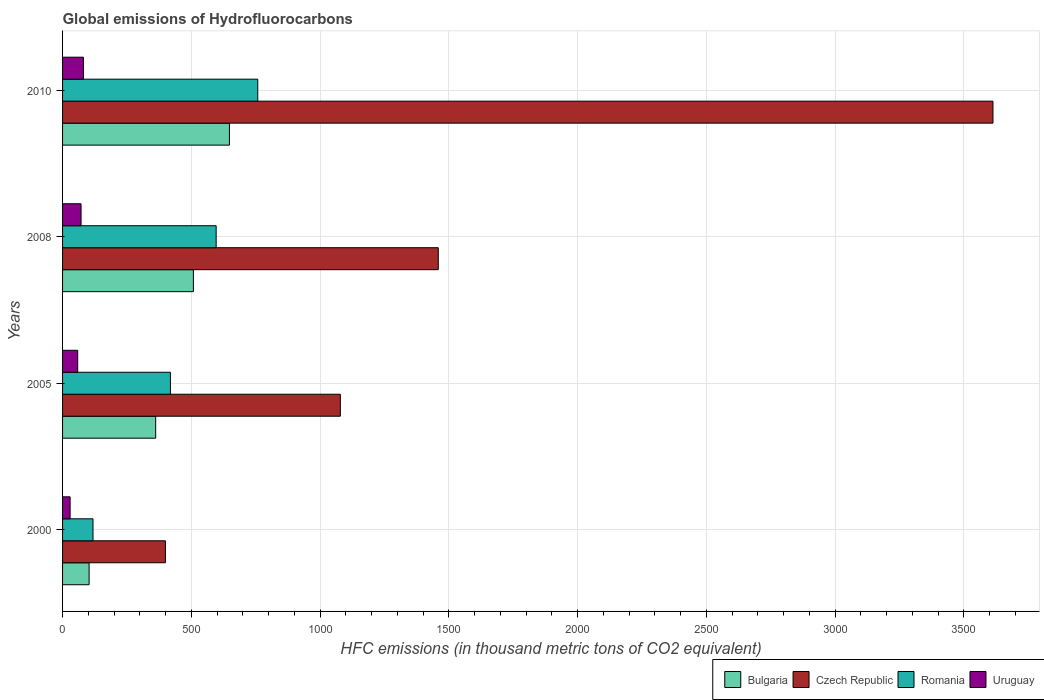How many groups of bars are there?
Make the answer very short. 4. How many bars are there on the 4th tick from the bottom?
Provide a succinct answer. 4. What is the label of the 2nd group of bars from the top?
Your response must be concise. 2008. What is the global emissions of Hydrofluorocarbons in Bulgaria in 2008?
Provide a succinct answer. 508. Across all years, what is the maximum global emissions of Hydrofluorocarbons in Bulgaria?
Give a very brief answer. 648. Across all years, what is the minimum global emissions of Hydrofluorocarbons in Romania?
Offer a terse response. 118.2. In which year was the global emissions of Hydrofluorocarbons in Bulgaria maximum?
Offer a terse response. 2010. What is the total global emissions of Hydrofluorocarbons in Czech Republic in the graph?
Offer a very short reply. 6550.2. What is the difference between the global emissions of Hydrofluorocarbons in Czech Republic in 2000 and that in 2005?
Make the answer very short. -679.2. What is the difference between the global emissions of Hydrofluorocarbons in Bulgaria in 2000 and the global emissions of Hydrofluorocarbons in Uruguay in 2008?
Offer a very short reply. 31.3. What is the average global emissions of Hydrofluorocarbons in Bulgaria per year?
Keep it short and to the point. 405.18. In the year 2008, what is the difference between the global emissions of Hydrofluorocarbons in Romania and global emissions of Hydrofluorocarbons in Bulgaria?
Offer a terse response. 88.4. In how many years, is the global emissions of Hydrofluorocarbons in Czech Republic greater than 400 thousand metric tons?
Provide a succinct answer. 3. What is the ratio of the global emissions of Hydrofluorocarbons in Uruguay in 2000 to that in 2008?
Provide a short and direct response. 0.41. Is the global emissions of Hydrofluorocarbons in Uruguay in 2000 less than that in 2005?
Make the answer very short. Yes. Is the difference between the global emissions of Hydrofluorocarbons in Romania in 2000 and 2005 greater than the difference between the global emissions of Hydrofluorocarbons in Bulgaria in 2000 and 2005?
Make the answer very short. No. What is the difference between the highest and the second highest global emissions of Hydrofluorocarbons in Romania?
Ensure brevity in your answer.  161.6. What is the difference between the highest and the lowest global emissions of Hydrofluorocarbons in Bulgaria?
Provide a short and direct response. 544.9. Is it the case that in every year, the sum of the global emissions of Hydrofluorocarbons in Romania and global emissions of Hydrofluorocarbons in Czech Republic is greater than the sum of global emissions of Hydrofluorocarbons in Uruguay and global emissions of Hydrofluorocarbons in Bulgaria?
Provide a short and direct response. Yes. What does the 1st bar from the top in 2008 represents?
Provide a short and direct response. Uruguay. What does the 3rd bar from the bottom in 2010 represents?
Your answer should be very brief. Romania. Is it the case that in every year, the sum of the global emissions of Hydrofluorocarbons in Uruguay and global emissions of Hydrofluorocarbons in Czech Republic is greater than the global emissions of Hydrofluorocarbons in Romania?
Your answer should be very brief. Yes. How many bars are there?
Provide a short and direct response. 16. Does the graph contain any zero values?
Your response must be concise. No. Does the graph contain grids?
Your response must be concise. Yes. Where does the legend appear in the graph?
Your answer should be compact. Bottom right. What is the title of the graph?
Your answer should be very brief. Global emissions of Hydrofluorocarbons. What is the label or title of the X-axis?
Offer a very short reply. HFC emissions (in thousand metric tons of CO2 equivalent). What is the label or title of the Y-axis?
Your answer should be compact. Years. What is the HFC emissions (in thousand metric tons of CO2 equivalent) of Bulgaria in 2000?
Provide a short and direct response. 103.1. What is the HFC emissions (in thousand metric tons of CO2 equivalent) in Czech Republic in 2000?
Your answer should be very brief. 399.5. What is the HFC emissions (in thousand metric tons of CO2 equivalent) in Romania in 2000?
Provide a short and direct response. 118.2. What is the HFC emissions (in thousand metric tons of CO2 equivalent) of Uruguay in 2000?
Offer a very short reply. 29.3. What is the HFC emissions (in thousand metric tons of CO2 equivalent) in Bulgaria in 2005?
Your response must be concise. 361.6. What is the HFC emissions (in thousand metric tons of CO2 equivalent) in Czech Republic in 2005?
Give a very brief answer. 1078.7. What is the HFC emissions (in thousand metric tons of CO2 equivalent) of Romania in 2005?
Offer a very short reply. 418.8. What is the HFC emissions (in thousand metric tons of CO2 equivalent) in Uruguay in 2005?
Your answer should be very brief. 58.7. What is the HFC emissions (in thousand metric tons of CO2 equivalent) in Bulgaria in 2008?
Provide a succinct answer. 508. What is the HFC emissions (in thousand metric tons of CO2 equivalent) of Czech Republic in 2008?
Keep it short and to the point. 1459. What is the HFC emissions (in thousand metric tons of CO2 equivalent) of Romania in 2008?
Provide a succinct answer. 596.4. What is the HFC emissions (in thousand metric tons of CO2 equivalent) of Uruguay in 2008?
Ensure brevity in your answer.  71.8. What is the HFC emissions (in thousand metric tons of CO2 equivalent) in Bulgaria in 2010?
Your answer should be compact. 648. What is the HFC emissions (in thousand metric tons of CO2 equivalent) in Czech Republic in 2010?
Your answer should be very brief. 3613. What is the HFC emissions (in thousand metric tons of CO2 equivalent) of Romania in 2010?
Your response must be concise. 758. What is the HFC emissions (in thousand metric tons of CO2 equivalent) of Uruguay in 2010?
Your answer should be very brief. 81. Across all years, what is the maximum HFC emissions (in thousand metric tons of CO2 equivalent) of Bulgaria?
Keep it short and to the point. 648. Across all years, what is the maximum HFC emissions (in thousand metric tons of CO2 equivalent) in Czech Republic?
Your answer should be very brief. 3613. Across all years, what is the maximum HFC emissions (in thousand metric tons of CO2 equivalent) of Romania?
Provide a short and direct response. 758. Across all years, what is the minimum HFC emissions (in thousand metric tons of CO2 equivalent) in Bulgaria?
Your answer should be very brief. 103.1. Across all years, what is the minimum HFC emissions (in thousand metric tons of CO2 equivalent) of Czech Republic?
Offer a terse response. 399.5. Across all years, what is the minimum HFC emissions (in thousand metric tons of CO2 equivalent) in Romania?
Give a very brief answer. 118.2. Across all years, what is the minimum HFC emissions (in thousand metric tons of CO2 equivalent) in Uruguay?
Ensure brevity in your answer.  29.3. What is the total HFC emissions (in thousand metric tons of CO2 equivalent) of Bulgaria in the graph?
Your answer should be compact. 1620.7. What is the total HFC emissions (in thousand metric tons of CO2 equivalent) in Czech Republic in the graph?
Your answer should be very brief. 6550.2. What is the total HFC emissions (in thousand metric tons of CO2 equivalent) in Romania in the graph?
Give a very brief answer. 1891.4. What is the total HFC emissions (in thousand metric tons of CO2 equivalent) in Uruguay in the graph?
Keep it short and to the point. 240.8. What is the difference between the HFC emissions (in thousand metric tons of CO2 equivalent) of Bulgaria in 2000 and that in 2005?
Offer a very short reply. -258.5. What is the difference between the HFC emissions (in thousand metric tons of CO2 equivalent) in Czech Republic in 2000 and that in 2005?
Your answer should be very brief. -679.2. What is the difference between the HFC emissions (in thousand metric tons of CO2 equivalent) in Romania in 2000 and that in 2005?
Offer a very short reply. -300.6. What is the difference between the HFC emissions (in thousand metric tons of CO2 equivalent) of Uruguay in 2000 and that in 2005?
Offer a terse response. -29.4. What is the difference between the HFC emissions (in thousand metric tons of CO2 equivalent) of Bulgaria in 2000 and that in 2008?
Keep it short and to the point. -404.9. What is the difference between the HFC emissions (in thousand metric tons of CO2 equivalent) of Czech Republic in 2000 and that in 2008?
Offer a very short reply. -1059.5. What is the difference between the HFC emissions (in thousand metric tons of CO2 equivalent) in Romania in 2000 and that in 2008?
Your answer should be compact. -478.2. What is the difference between the HFC emissions (in thousand metric tons of CO2 equivalent) in Uruguay in 2000 and that in 2008?
Make the answer very short. -42.5. What is the difference between the HFC emissions (in thousand metric tons of CO2 equivalent) of Bulgaria in 2000 and that in 2010?
Your answer should be very brief. -544.9. What is the difference between the HFC emissions (in thousand metric tons of CO2 equivalent) of Czech Republic in 2000 and that in 2010?
Keep it short and to the point. -3213.5. What is the difference between the HFC emissions (in thousand metric tons of CO2 equivalent) of Romania in 2000 and that in 2010?
Offer a very short reply. -639.8. What is the difference between the HFC emissions (in thousand metric tons of CO2 equivalent) in Uruguay in 2000 and that in 2010?
Make the answer very short. -51.7. What is the difference between the HFC emissions (in thousand metric tons of CO2 equivalent) in Bulgaria in 2005 and that in 2008?
Make the answer very short. -146.4. What is the difference between the HFC emissions (in thousand metric tons of CO2 equivalent) in Czech Republic in 2005 and that in 2008?
Give a very brief answer. -380.3. What is the difference between the HFC emissions (in thousand metric tons of CO2 equivalent) of Romania in 2005 and that in 2008?
Ensure brevity in your answer.  -177.6. What is the difference between the HFC emissions (in thousand metric tons of CO2 equivalent) of Bulgaria in 2005 and that in 2010?
Provide a succinct answer. -286.4. What is the difference between the HFC emissions (in thousand metric tons of CO2 equivalent) of Czech Republic in 2005 and that in 2010?
Your answer should be very brief. -2534.3. What is the difference between the HFC emissions (in thousand metric tons of CO2 equivalent) in Romania in 2005 and that in 2010?
Give a very brief answer. -339.2. What is the difference between the HFC emissions (in thousand metric tons of CO2 equivalent) in Uruguay in 2005 and that in 2010?
Give a very brief answer. -22.3. What is the difference between the HFC emissions (in thousand metric tons of CO2 equivalent) in Bulgaria in 2008 and that in 2010?
Provide a short and direct response. -140. What is the difference between the HFC emissions (in thousand metric tons of CO2 equivalent) of Czech Republic in 2008 and that in 2010?
Make the answer very short. -2154. What is the difference between the HFC emissions (in thousand metric tons of CO2 equivalent) in Romania in 2008 and that in 2010?
Offer a very short reply. -161.6. What is the difference between the HFC emissions (in thousand metric tons of CO2 equivalent) in Uruguay in 2008 and that in 2010?
Make the answer very short. -9.2. What is the difference between the HFC emissions (in thousand metric tons of CO2 equivalent) of Bulgaria in 2000 and the HFC emissions (in thousand metric tons of CO2 equivalent) of Czech Republic in 2005?
Offer a terse response. -975.6. What is the difference between the HFC emissions (in thousand metric tons of CO2 equivalent) in Bulgaria in 2000 and the HFC emissions (in thousand metric tons of CO2 equivalent) in Romania in 2005?
Your answer should be very brief. -315.7. What is the difference between the HFC emissions (in thousand metric tons of CO2 equivalent) of Bulgaria in 2000 and the HFC emissions (in thousand metric tons of CO2 equivalent) of Uruguay in 2005?
Provide a succinct answer. 44.4. What is the difference between the HFC emissions (in thousand metric tons of CO2 equivalent) in Czech Republic in 2000 and the HFC emissions (in thousand metric tons of CO2 equivalent) in Romania in 2005?
Make the answer very short. -19.3. What is the difference between the HFC emissions (in thousand metric tons of CO2 equivalent) of Czech Republic in 2000 and the HFC emissions (in thousand metric tons of CO2 equivalent) of Uruguay in 2005?
Offer a very short reply. 340.8. What is the difference between the HFC emissions (in thousand metric tons of CO2 equivalent) of Romania in 2000 and the HFC emissions (in thousand metric tons of CO2 equivalent) of Uruguay in 2005?
Your response must be concise. 59.5. What is the difference between the HFC emissions (in thousand metric tons of CO2 equivalent) in Bulgaria in 2000 and the HFC emissions (in thousand metric tons of CO2 equivalent) in Czech Republic in 2008?
Offer a terse response. -1355.9. What is the difference between the HFC emissions (in thousand metric tons of CO2 equivalent) in Bulgaria in 2000 and the HFC emissions (in thousand metric tons of CO2 equivalent) in Romania in 2008?
Your response must be concise. -493.3. What is the difference between the HFC emissions (in thousand metric tons of CO2 equivalent) in Bulgaria in 2000 and the HFC emissions (in thousand metric tons of CO2 equivalent) in Uruguay in 2008?
Keep it short and to the point. 31.3. What is the difference between the HFC emissions (in thousand metric tons of CO2 equivalent) in Czech Republic in 2000 and the HFC emissions (in thousand metric tons of CO2 equivalent) in Romania in 2008?
Offer a terse response. -196.9. What is the difference between the HFC emissions (in thousand metric tons of CO2 equivalent) of Czech Republic in 2000 and the HFC emissions (in thousand metric tons of CO2 equivalent) of Uruguay in 2008?
Your answer should be compact. 327.7. What is the difference between the HFC emissions (in thousand metric tons of CO2 equivalent) of Romania in 2000 and the HFC emissions (in thousand metric tons of CO2 equivalent) of Uruguay in 2008?
Your answer should be compact. 46.4. What is the difference between the HFC emissions (in thousand metric tons of CO2 equivalent) in Bulgaria in 2000 and the HFC emissions (in thousand metric tons of CO2 equivalent) in Czech Republic in 2010?
Offer a very short reply. -3509.9. What is the difference between the HFC emissions (in thousand metric tons of CO2 equivalent) of Bulgaria in 2000 and the HFC emissions (in thousand metric tons of CO2 equivalent) of Romania in 2010?
Make the answer very short. -654.9. What is the difference between the HFC emissions (in thousand metric tons of CO2 equivalent) of Bulgaria in 2000 and the HFC emissions (in thousand metric tons of CO2 equivalent) of Uruguay in 2010?
Keep it short and to the point. 22.1. What is the difference between the HFC emissions (in thousand metric tons of CO2 equivalent) in Czech Republic in 2000 and the HFC emissions (in thousand metric tons of CO2 equivalent) in Romania in 2010?
Make the answer very short. -358.5. What is the difference between the HFC emissions (in thousand metric tons of CO2 equivalent) of Czech Republic in 2000 and the HFC emissions (in thousand metric tons of CO2 equivalent) of Uruguay in 2010?
Provide a short and direct response. 318.5. What is the difference between the HFC emissions (in thousand metric tons of CO2 equivalent) of Romania in 2000 and the HFC emissions (in thousand metric tons of CO2 equivalent) of Uruguay in 2010?
Give a very brief answer. 37.2. What is the difference between the HFC emissions (in thousand metric tons of CO2 equivalent) in Bulgaria in 2005 and the HFC emissions (in thousand metric tons of CO2 equivalent) in Czech Republic in 2008?
Ensure brevity in your answer.  -1097.4. What is the difference between the HFC emissions (in thousand metric tons of CO2 equivalent) in Bulgaria in 2005 and the HFC emissions (in thousand metric tons of CO2 equivalent) in Romania in 2008?
Give a very brief answer. -234.8. What is the difference between the HFC emissions (in thousand metric tons of CO2 equivalent) of Bulgaria in 2005 and the HFC emissions (in thousand metric tons of CO2 equivalent) of Uruguay in 2008?
Offer a very short reply. 289.8. What is the difference between the HFC emissions (in thousand metric tons of CO2 equivalent) in Czech Republic in 2005 and the HFC emissions (in thousand metric tons of CO2 equivalent) in Romania in 2008?
Keep it short and to the point. 482.3. What is the difference between the HFC emissions (in thousand metric tons of CO2 equivalent) of Czech Republic in 2005 and the HFC emissions (in thousand metric tons of CO2 equivalent) of Uruguay in 2008?
Offer a terse response. 1006.9. What is the difference between the HFC emissions (in thousand metric tons of CO2 equivalent) of Romania in 2005 and the HFC emissions (in thousand metric tons of CO2 equivalent) of Uruguay in 2008?
Your response must be concise. 347. What is the difference between the HFC emissions (in thousand metric tons of CO2 equivalent) of Bulgaria in 2005 and the HFC emissions (in thousand metric tons of CO2 equivalent) of Czech Republic in 2010?
Your answer should be very brief. -3251.4. What is the difference between the HFC emissions (in thousand metric tons of CO2 equivalent) of Bulgaria in 2005 and the HFC emissions (in thousand metric tons of CO2 equivalent) of Romania in 2010?
Provide a succinct answer. -396.4. What is the difference between the HFC emissions (in thousand metric tons of CO2 equivalent) of Bulgaria in 2005 and the HFC emissions (in thousand metric tons of CO2 equivalent) of Uruguay in 2010?
Your answer should be compact. 280.6. What is the difference between the HFC emissions (in thousand metric tons of CO2 equivalent) in Czech Republic in 2005 and the HFC emissions (in thousand metric tons of CO2 equivalent) in Romania in 2010?
Your response must be concise. 320.7. What is the difference between the HFC emissions (in thousand metric tons of CO2 equivalent) of Czech Republic in 2005 and the HFC emissions (in thousand metric tons of CO2 equivalent) of Uruguay in 2010?
Make the answer very short. 997.7. What is the difference between the HFC emissions (in thousand metric tons of CO2 equivalent) of Romania in 2005 and the HFC emissions (in thousand metric tons of CO2 equivalent) of Uruguay in 2010?
Ensure brevity in your answer.  337.8. What is the difference between the HFC emissions (in thousand metric tons of CO2 equivalent) of Bulgaria in 2008 and the HFC emissions (in thousand metric tons of CO2 equivalent) of Czech Republic in 2010?
Provide a succinct answer. -3105. What is the difference between the HFC emissions (in thousand metric tons of CO2 equivalent) in Bulgaria in 2008 and the HFC emissions (in thousand metric tons of CO2 equivalent) in Romania in 2010?
Your answer should be compact. -250. What is the difference between the HFC emissions (in thousand metric tons of CO2 equivalent) of Bulgaria in 2008 and the HFC emissions (in thousand metric tons of CO2 equivalent) of Uruguay in 2010?
Offer a very short reply. 427. What is the difference between the HFC emissions (in thousand metric tons of CO2 equivalent) of Czech Republic in 2008 and the HFC emissions (in thousand metric tons of CO2 equivalent) of Romania in 2010?
Offer a very short reply. 701. What is the difference between the HFC emissions (in thousand metric tons of CO2 equivalent) in Czech Republic in 2008 and the HFC emissions (in thousand metric tons of CO2 equivalent) in Uruguay in 2010?
Offer a terse response. 1378. What is the difference between the HFC emissions (in thousand metric tons of CO2 equivalent) of Romania in 2008 and the HFC emissions (in thousand metric tons of CO2 equivalent) of Uruguay in 2010?
Offer a terse response. 515.4. What is the average HFC emissions (in thousand metric tons of CO2 equivalent) of Bulgaria per year?
Keep it short and to the point. 405.18. What is the average HFC emissions (in thousand metric tons of CO2 equivalent) of Czech Republic per year?
Keep it short and to the point. 1637.55. What is the average HFC emissions (in thousand metric tons of CO2 equivalent) of Romania per year?
Your answer should be very brief. 472.85. What is the average HFC emissions (in thousand metric tons of CO2 equivalent) in Uruguay per year?
Ensure brevity in your answer.  60.2. In the year 2000, what is the difference between the HFC emissions (in thousand metric tons of CO2 equivalent) in Bulgaria and HFC emissions (in thousand metric tons of CO2 equivalent) in Czech Republic?
Keep it short and to the point. -296.4. In the year 2000, what is the difference between the HFC emissions (in thousand metric tons of CO2 equivalent) in Bulgaria and HFC emissions (in thousand metric tons of CO2 equivalent) in Romania?
Ensure brevity in your answer.  -15.1. In the year 2000, what is the difference between the HFC emissions (in thousand metric tons of CO2 equivalent) in Bulgaria and HFC emissions (in thousand metric tons of CO2 equivalent) in Uruguay?
Ensure brevity in your answer.  73.8. In the year 2000, what is the difference between the HFC emissions (in thousand metric tons of CO2 equivalent) in Czech Republic and HFC emissions (in thousand metric tons of CO2 equivalent) in Romania?
Give a very brief answer. 281.3. In the year 2000, what is the difference between the HFC emissions (in thousand metric tons of CO2 equivalent) in Czech Republic and HFC emissions (in thousand metric tons of CO2 equivalent) in Uruguay?
Offer a very short reply. 370.2. In the year 2000, what is the difference between the HFC emissions (in thousand metric tons of CO2 equivalent) of Romania and HFC emissions (in thousand metric tons of CO2 equivalent) of Uruguay?
Give a very brief answer. 88.9. In the year 2005, what is the difference between the HFC emissions (in thousand metric tons of CO2 equivalent) in Bulgaria and HFC emissions (in thousand metric tons of CO2 equivalent) in Czech Republic?
Your answer should be compact. -717.1. In the year 2005, what is the difference between the HFC emissions (in thousand metric tons of CO2 equivalent) in Bulgaria and HFC emissions (in thousand metric tons of CO2 equivalent) in Romania?
Keep it short and to the point. -57.2. In the year 2005, what is the difference between the HFC emissions (in thousand metric tons of CO2 equivalent) in Bulgaria and HFC emissions (in thousand metric tons of CO2 equivalent) in Uruguay?
Ensure brevity in your answer.  302.9. In the year 2005, what is the difference between the HFC emissions (in thousand metric tons of CO2 equivalent) in Czech Republic and HFC emissions (in thousand metric tons of CO2 equivalent) in Romania?
Provide a short and direct response. 659.9. In the year 2005, what is the difference between the HFC emissions (in thousand metric tons of CO2 equivalent) of Czech Republic and HFC emissions (in thousand metric tons of CO2 equivalent) of Uruguay?
Your response must be concise. 1020. In the year 2005, what is the difference between the HFC emissions (in thousand metric tons of CO2 equivalent) of Romania and HFC emissions (in thousand metric tons of CO2 equivalent) of Uruguay?
Keep it short and to the point. 360.1. In the year 2008, what is the difference between the HFC emissions (in thousand metric tons of CO2 equivalent) of Bulgaria and HFC emissions (in thousand metric tons of CO2 equivalent) of Czech Republic?
Provide a succinct answer. -951. In the year 2008, what is the difference between the HFC emissions (in thousand metric tons of CO2 equivalent) in Bulgaria and HFC emissions (in thousand metric tons of CO2 equivalent) in Romania?
Make the answer very short. -88.4. In the year 2008, what is the difference between the HFC emissions (in thousand metric tons of CO2 equivalent) in Bulgaria and HFC emissions (in thousand metric tons of CO2 equivalent) in Uruguay?
Offer a terse response. 436.2. In the year 2008, what is the difference between the HFC emissions (in thousand metric tons of CO2 equivalent) of Czech Republic and HFC emissions (in thousand metric tons of CO2 equivalent) of Romania?
Your answer should be compact. 862.6. In the year 2008, what is the difference between the HFC emissions (in thousand metric tons of CO2 equivalent) in Czech Republic and HFC emissions (in thousand metric tons of CO2 equivalent) in Uruguay?
Keep it short and to the point. 1387.2. In the year 2008, what is the difference between the HFC emissions (in thousand metric tons of CO2 equivalent) of Romania and HFC emissions (in thousand metric tons of CO2 equivalent) of Uruguay?
Make the answer very short. 524.6. In the year 2010, what is the difference between the HFC emissions (in thousand metric tons of CO2 equivalent) in Bulgaria and HFC emissions (in thousand metric tons of CO2 equivalent) in Czech Republic?
Offer a very short reply. -2965. In the year 2010, what is the difference between the HFC emissions (in thousand metric tons of CO2 equivalent) of Bulgaria and HFC emissions (in thousand metric tons of CO2 equivalent) of Romania?
Offer a very short reply. -110. In the year 2010, what is the difference between the HFC emissions (in thousand metric tons of CO2 equivalent) of Bulgaria and HFC emissions (in thousand metric tons of CO2 equivalent) of Uruguay?
Your answer should be very brief. 567. In the year 2010, what is the difference between the HFC emissions (in thousand metric tons of CO2 equivalent) in Czech Republic and HFC emissions (in thousand metric tons of CO2 equivalent) in Romania?
Your answer should be very brief. 2855. In the year 2010, what is the difference between the HFC emissions (in thousand metric tons of CO2 equivalent) in Czech Republic and HFC emissions (in thousand metric tons of CO2 equivalent) in Uruguay?
Your response must be concise. 3532. In the year 2010, what is the difference between the HFC emissions (in thousand metric tons of CO2 equivalent) of Romania and HFC emissions (in thousand metric tons of CO2 equivalent) of Uruguay?
Your answer should be very brief. 677. What is the ratio of the HFC emissions (in thousand metric tons of CO2 equivalent) in Bulgaria in 2000 to that in 2005?
Give a very brief answer. 0.29. What is the ratio of the HFC emissions (in thousand metric tons of CO2 equivalent) in Czech Republic in 2000 to that in 2005?
Make the answer very short. 0.37. What is the ratio of the HFC emissions (in thousand metric tons of CO2 equivalent) in Romania in 2000 to that in 2005?
Provide a succinct answer. 0.28. What is the ratio of the HFC emissions (in thousand metric tons of CO2 equivalent) in Uruguay in 2000 to that in 2005?
Give a very brief answer. 0.5. What is the ratio of the HFC emissions (in thousand metric tons of CO2 equivalent) of Bulgaria in 2000 to that in 2008?
Keep it short and to the point. 0.2. What is the ratio of the HFC emissions (in thousand metric tons of CO2 equivalent) in Czech Republic in 2000 to that in 2008?
Offer a terse response. 0.27. What is the ratio of the HFC emissions (in thousand metric tons of CO2 equivalent) in Romania in 2000 to that in 2008?
Offer a terse response. 0.2. What is the ratio of the HFC emissions (in thousand metric tons of CO2 equivalent) of Uruguay in 2000 to that in 2008?
Provide a short and direct response. 0.41. What is the ratio of the HFC emissions (in thousand metric tons of CO2 equivalent) in Bulgaria in 2000 to that in 2010?
Provide a succinct answer. 0.16. What is the ratio of the HFC emissions (in thousand metric tons of CO2 equivalent) in Czech Republic in 2000 to that in 2010?
Offer a very short reply. 0.11. What is the ratio of the HFC emissions (in thousand metric tons of CO2 equivalent) in Romania in 2000 to that in 2010?
Provide a succinct answer. 0.16. What is the ratio of the HFC emissions (in thousand metric tons of CO2 equivalent) in Uruguay in 2000 to that in 2010?
Your answer should be compact. 0.36. What is the ratio of the HFC emissions (in thousand metric tons of CO2 equivalent) of Bulgaria in 2005 to that in 2008?
Keep it short and to the point. 0.71. What is the ratio of the HFC emissions (in thousand metric tons of CO2 equivalent) in Czech Republic in 2005 to that in 2008?
Provide a succinct answer. 0.74. What is the ratio of the HFC emissions (in thousand metric tons of CO2 equivalent) in Romania in 2005 to that in 2008?
Give a very brief answer. 0.7. What is the ratio of the HFC emissions (in thousand metric tons of CO2 equivalent) of Uruguay in 2005 to that in 2008?
Provide a succinct answer. 0.82. What is the ratio of the HFC emissions (in thousand metric tons of CO2 equivalent) of Bulgaria in 2005 to that in 2010?
Keep it short and to the point. 0.56. What is the ratio of the HFC emissions (in thousand metric tons of CO2 equivalent) in Czech Republic in 2005 to that in 2010?
Your response must be concise. 0.3. What is the ratio of the HFC emissions (in thousand metric tons of CO2 equivalent) in Romania in 2005 to that in 2010?
Keep it short and to the point. 0.55. What is the ratio of the HFC emissions (in thousand metric tons of CO2 equivalent) in Uruguay in 2005 to that in 2010?
Offer a terse response. 0.72. What is the ratio of the HFC emissions (in thousand metric tons of CO2 equivalent) in Bulgaria in 2008 to that in 2010?
Give a very brief answer. 0.78. What is the ratio of the HFC emissions (in thousand metric tons of CO2 equivalent) of Czech Republic in 2008 to that in 2010?
Keep it short and to the point. 0.4. What is the ratio of the HFC emissions (in thousand metric tons of CO2 equivalent) of Romania in 2008 to that in 2010?
Keep it short and to the point. 0.79. What is the ratio of the HFC emissions (in thousand metric tons of CO2 equivalent) of Uruguay in 2008 to that in 2010?
Ensure brevity in your answer.  0.89. What is the difference between the highest and the second highest HFC emissions (in thousand metric tons of CO2 equivalent) of Bulgaria?
Ensure brevity in your answer.  140. What is the difference between the highest and the second highest HFC emissions (in thousand metric tons of CO2 equivalent) of Czech Republic?
Your answer should be compact. 2154. What is the difference between the highest and the second highest HFC emissions (in thousand metric tons of CO2 equivalent) of Romania?
Keep it short and to the point. 161.6. What is the difference between the highest and the second highest HFC emissions (in thousand metric tons of CO2 equivalent) of Uruguay?
Offer a very short reply. 9.2. What is the difference between the highest and the lowest HFC emissions (in thousand metric tons of CO2 equivalent) of Bulgaria?
Keep it short and to the point. 544.9. What is the difference between the highest and the lowest HFC emissions (in thousand metric tons of CO2 equivalent) in Czech Republic?
Ensure brevity in your answer.  3213.5. What is the difference between the highest and the lowest HFC emissions (in thousand metric tons of CO2 equivalent) in Romania?
Ensure brevity in your answer.  639.8. What is the difference between the highest and the lowest HFC emissions (in thousand metric tons of CO2 equivalent) in Uruguay?
Keep it short and to the point. 51.7. 